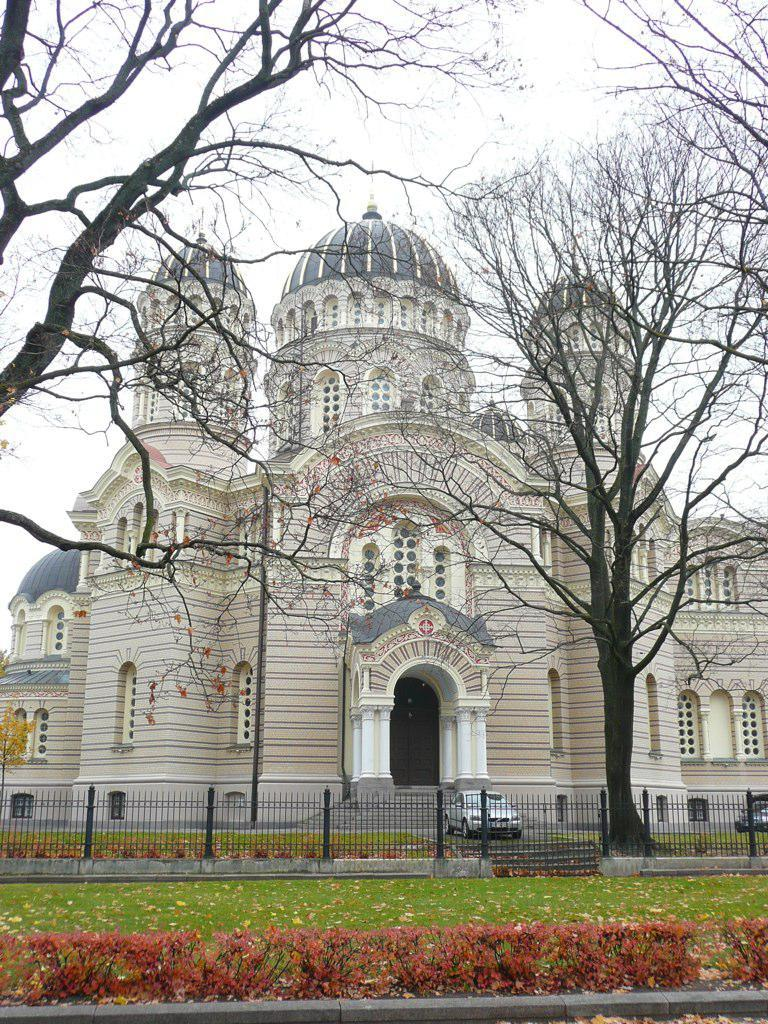What type of vegetation can be seen in the image? There is grass and plants visible in the image. What type of structure is present in the image? There is a fence in the image. What else can be seen in the image besides vegetation and structures? There are trees, buildings, and a car visible in the image. What part of the natural environment is visible in the image? The sky is visible in the image. Can you see any icicles hanging from the trees in the image? There are no icicles visible in the image; it appears to be a warm and sunny day. What type of corn is growing in the field in the image? There is no corn present in the image; it features grass, plants, trees, buildings, a car, and a fence. 